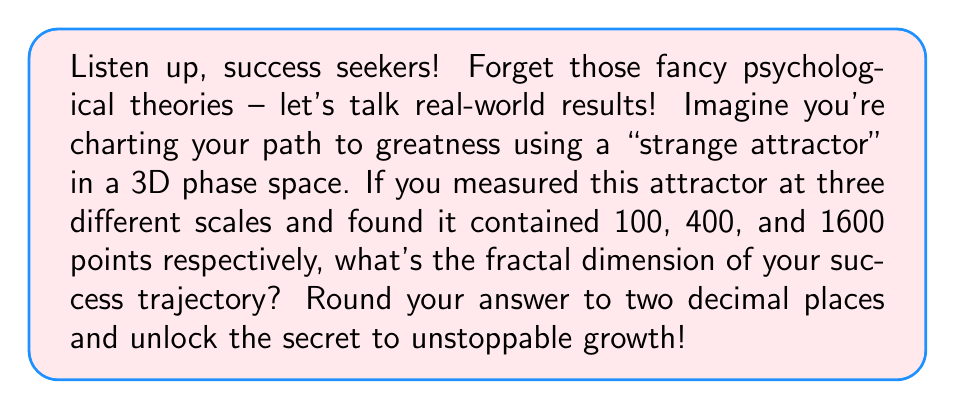Can you answer this question? Alright, achievers, let's break this down into simple, actionable steps:

1) The fractal dimension is all about how the complexity of a pattern changes with scale. We're going to use the box-counting method, which is like organizing your goals into increasingly smaller action items.

2) We have measurements at three scales. Let's call the smallest scale 1, the middle scale 2, and the largest scale 4.

3) The fractal dimension $D$ is given by the formula:

   $$D = \frac{\log(N_2/N_1)}{\log(r_1/r_2)}$$

   where $N_2$ and $N_1$ are the number of points at two different scales, and $r_1$ and $r_2$ are the corresponding scale factors.

4) Let's use the smallest and largest scales:
   $N_2 = 1600$, $N_1 = 100$, $r_1 = 1$, $r_2 = 4$

5) Plugging these into our success formula:

   $$D = \frac{\log(1600/100)}{\log(1/4)} = \frac{\log(16)}{\log(1/4)}$$

6) Simplify:
   $$D = \frac{\log(16)}{-\log(4)} = \frac{4\log(2)}{-2\log(2)} = -2$$

7) Take the absolute value (because dimensions are always positive) and round to two decimal places:

   $$D \approx 2.00$$

There you have it! Your success trajectory has a fractal dimension of 2.00. This means your path to greatness is as complex and multifaceted as a 2D surface – rich with opportunities and challenges to overcome!
Answer: 2.00 